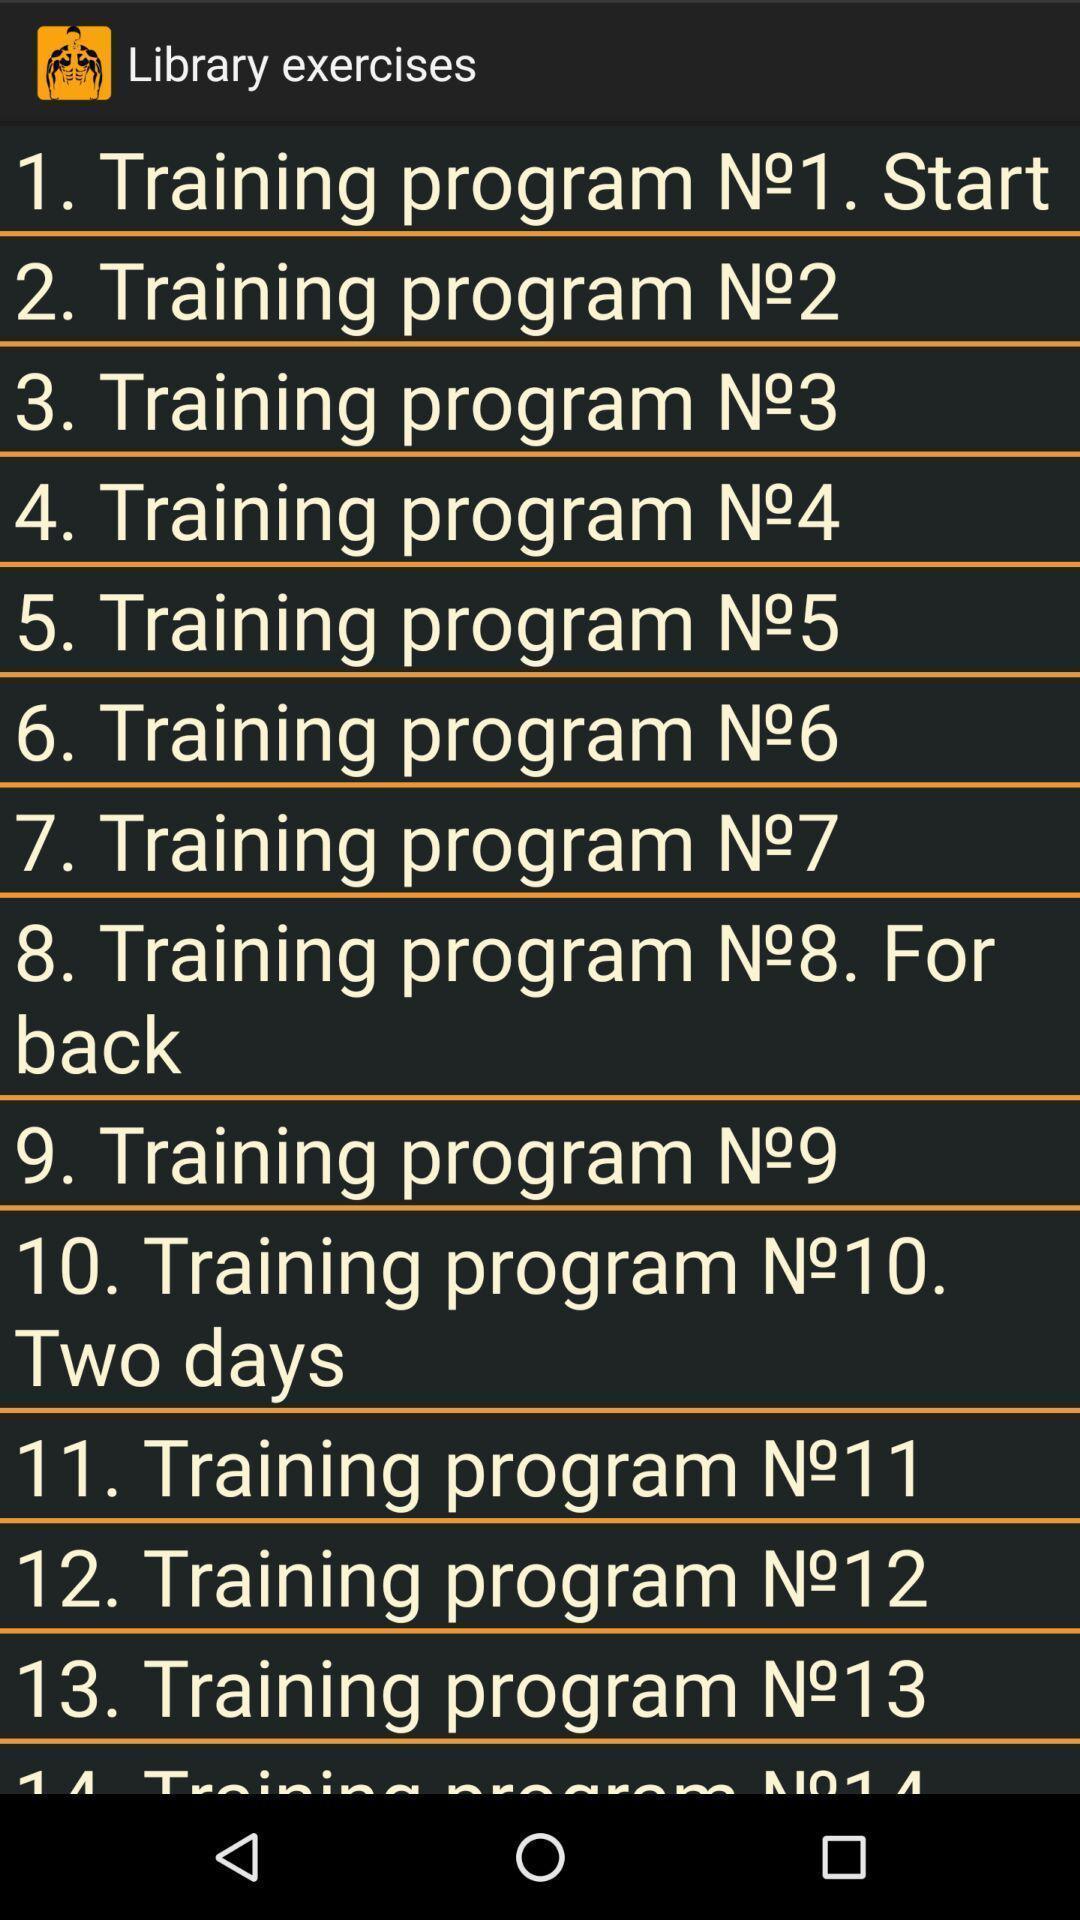Explain what's happening in this screen capture. Screen page of a fitness application. 